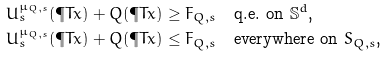<formula> <loc_0><loc_0><loc_500><loc_500>U _ { s } ^ { \mu _ { Q , s } } ( \P T { x } ) + Q ( \P T { x } ) & \geq F _ { Q , s } \quad \text {q.e. on $\mathbb{S}^{d}$,} \\ U _ { s } ^ { \mu _ { Q , s } } ( \P T { x } ) + Q ( \P T { x } ) & \leq F _ { Q , s } \quad \text {everywhere on $S_{Q,s}$,}</formula> 